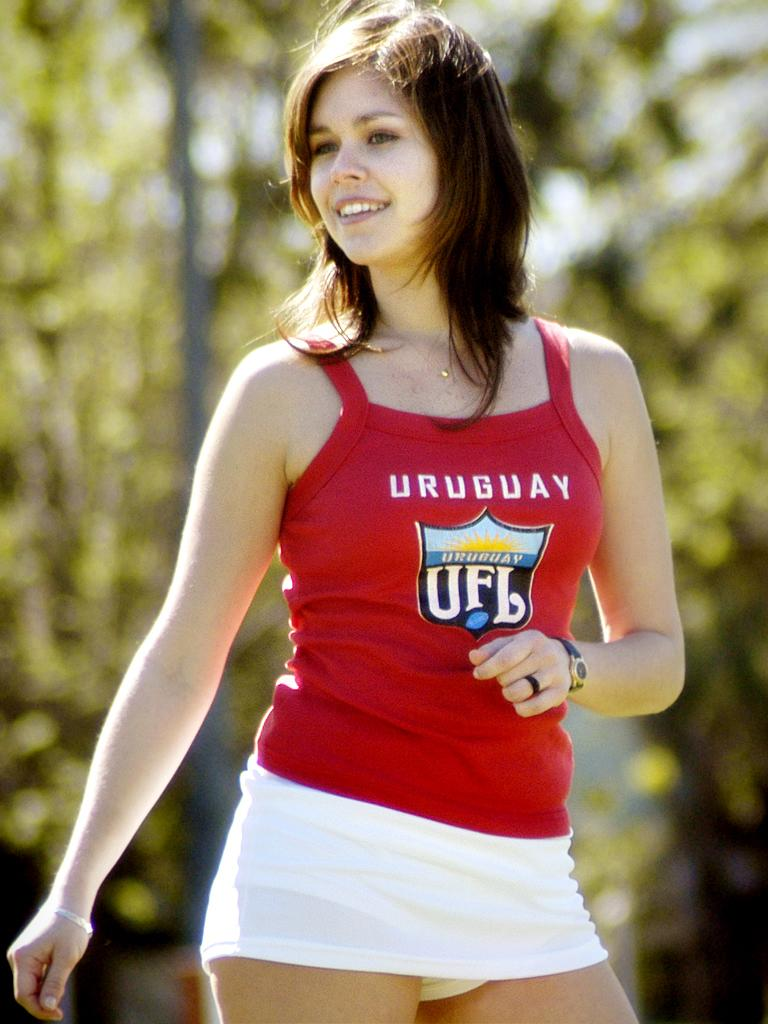<image>
Give a short and clear explanation of the subsequent image. The young lady is wearing a red tank top that says URUGUAY UFL on the front of it. 